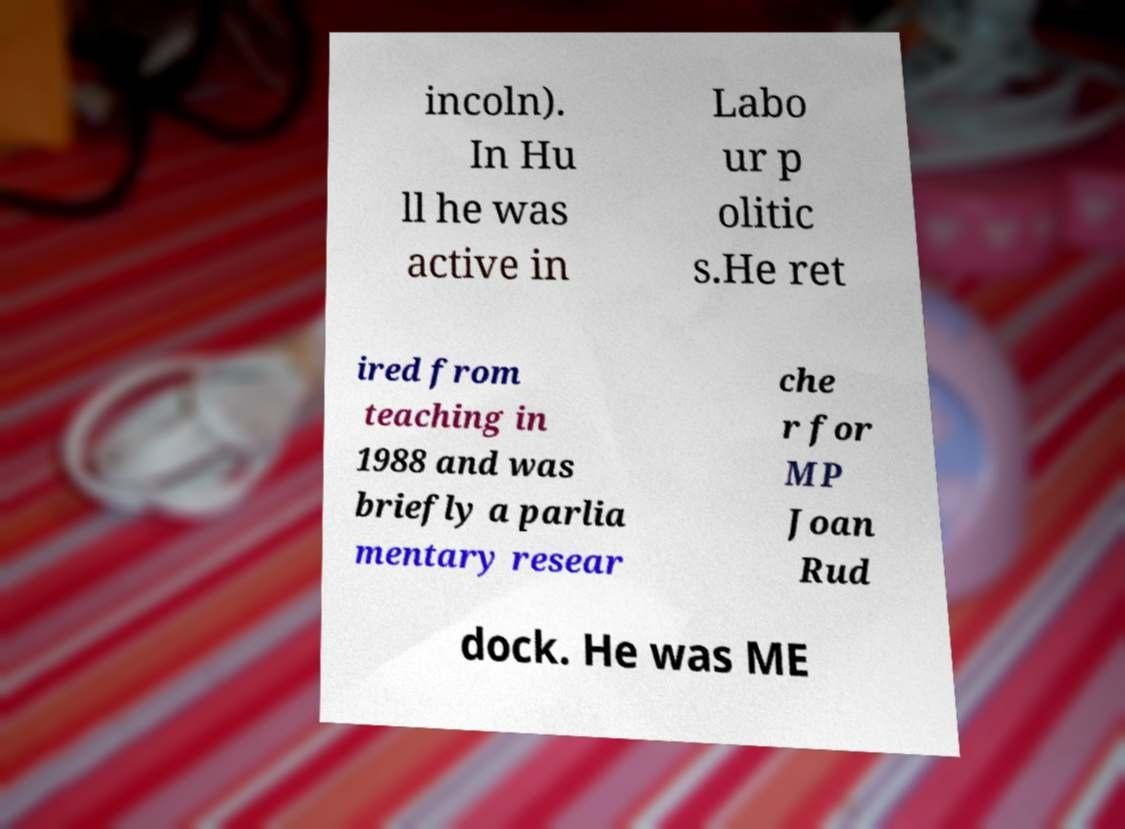Please identify and transcribe the text found in this image. incoln). In Hu ll he was active in Labo ur p olitic s.He ret ired from teaching in 1988 and was briefly a parlia mentary resear che r for MP Joan Rud dock. He was ME 